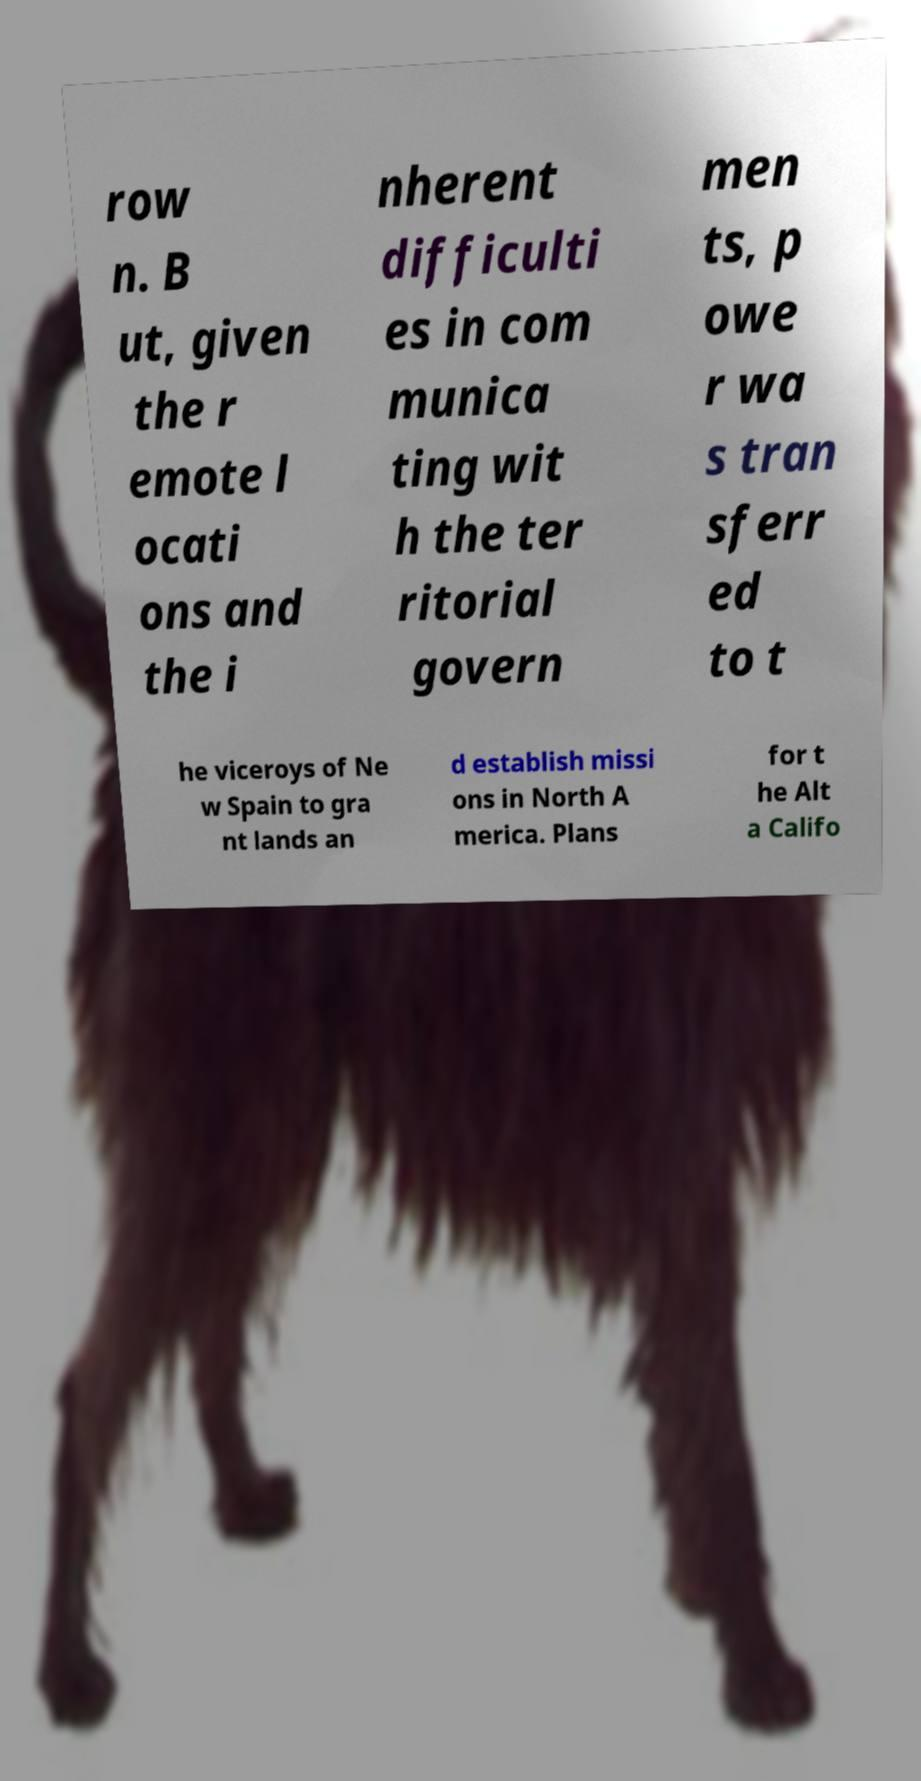Can you read and provide the text displayed in the image?This photo seems to have some interesting text. Can you extract and type it out for me? row n. B ut, given the r emote l ocati ons and the i nherent difficulti es in com munica ting wit h the ter ritorial govern men ts, p owe r wa s tran sferr ed to t he viceroys of Ne w Spain to gra nt lands an d establish missi ons in North A merica. Plans for t he Alt a Califo 